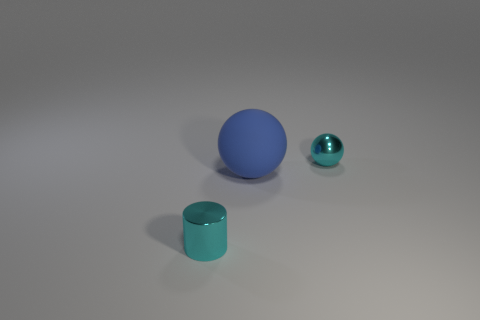Add 1 cyan metal spheres. How many objects exist? 4 Subtract 0 purple blocks. How many objects are left? 3 Subtract all balls. How many objects are left? 1 Subtract 1 balls. How many balls are left? 1 Subtract all gray cylinders. Subtract all blue balls. How many cylinders are left? 1 Subtract all yellow cylinders. How many blue balls are left? 1 Subtract all big balls. Subtract all big spheres. How many objects are left? 1 Add 1 big blue objects. How many big blue objects are left? 2 Add 1 tiny cyan shiny things. How many tiny cyan shiny things exist? 3 